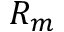Convert formula to latex. <formula><loc_0><loc_0><loc_500><loc_500>R _ { m }</formula> 